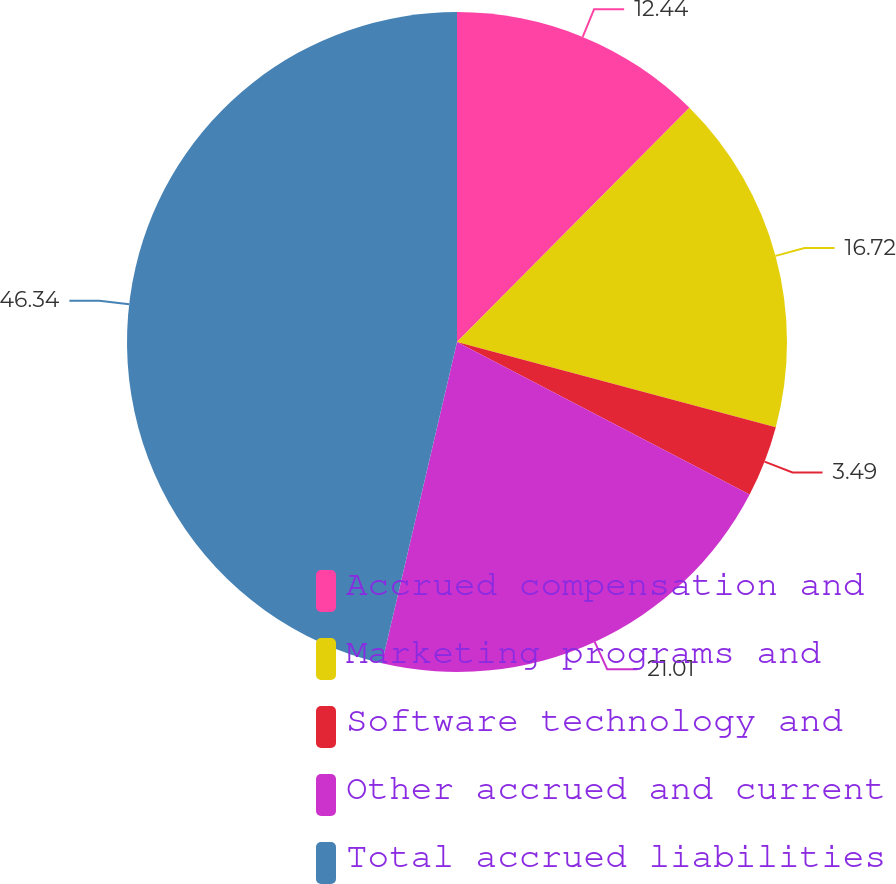<chart> <loc_0><loc_0><loc_500><loc_500><pie_chart><fcel>Accrued compensation and<fcel>Marketing programs and<fcel>Software technology and<fcel>Other accrued and current<fcel>Total accrued liabilities<nl><fcel>12.44%<fcel>16.72%<fcel>3.49%<fcel>21.01%<fcel>46.35%<nl></chart> 